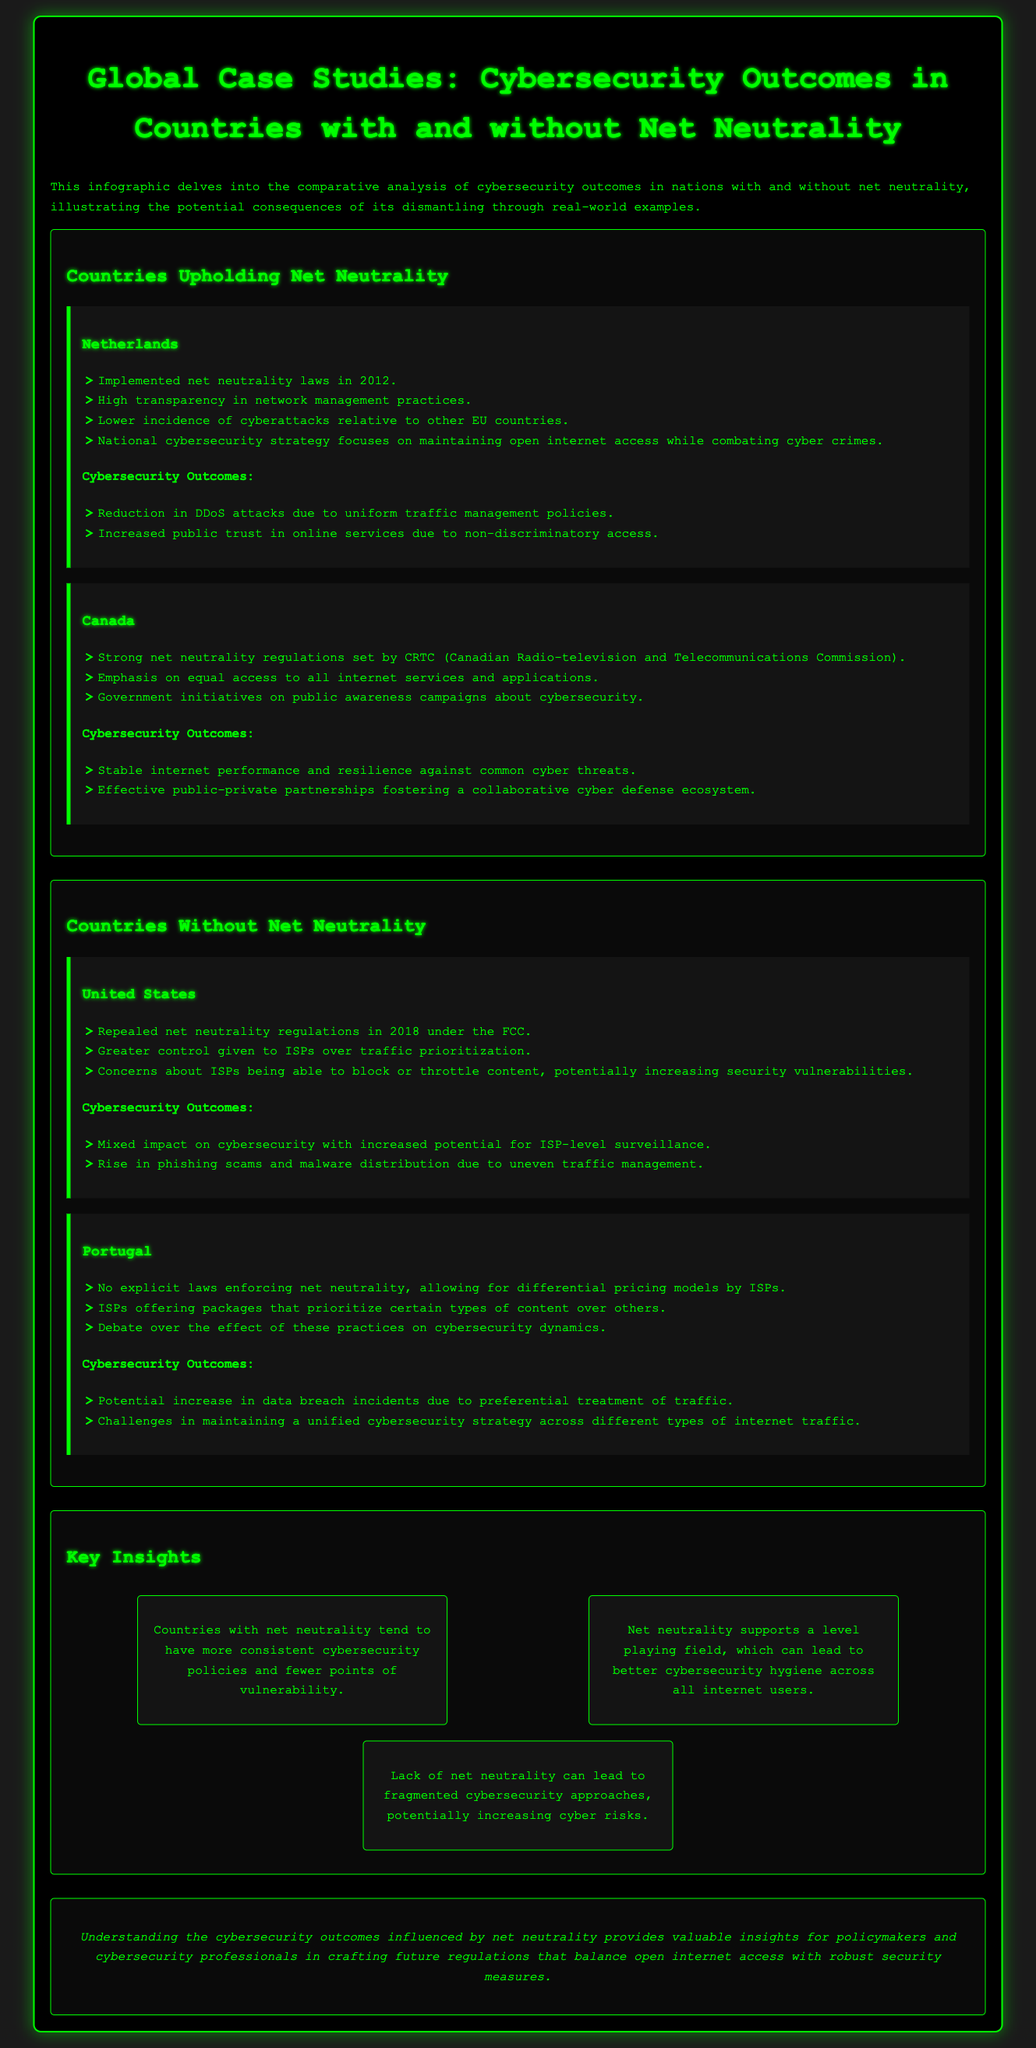What country implemented net neutrality laws in 2012? The document states that the Netherlands implemented net neutrality laws in 2012.
Answer: Netherlands What are two outcomes of net neutrality in the Netherlands? The document lists reduction in DDoS attacks and increased public trust in online services as outcomes.
Answer: Reduction in DDoS attacks, increased public trust What is the role of CRTC in Canada regarding net neutrality? The document notes that CRTC sets strong net neutrality regulations in Canada.
Answer: CRTC sets strong net neutrality regulations Which country repealed net neutrality regulations in 2018? According to the document, the United States repealed net neutrality regulations in 2018.
Answer: United States How does a lack of net neutrality impact cybersecurity according to the document? The document indicates that lack of net neutrality can lead to fragmented cybersecurity approaches.
Answer: Fragmented cybersecurity approaches What is one concern about ISPs in the United States regarding net neutrality? The document highlights concerns about ISPs being able to block or throttle content which could increase vulnerabilities.
Answer: Block or throttle content What do countries with net neutrality tend to have? The document states that countries with net neutrality tend to have more consistent cybersecurity policies.
Answer: More consistent cybersecurity policies What key insight addresses cybersecurity hygiene related to net neutrality? The document points out that net neutrality supports a level playing field, leading to better cybersecurity hygiene.
Answer: Better cybersecurity hygiene Which country has potential increases in data breach incidents? Portugal is indicated in the document as having potential increases in data breach incidents due to non-neutral traffic practices.
Answer: Portugal 